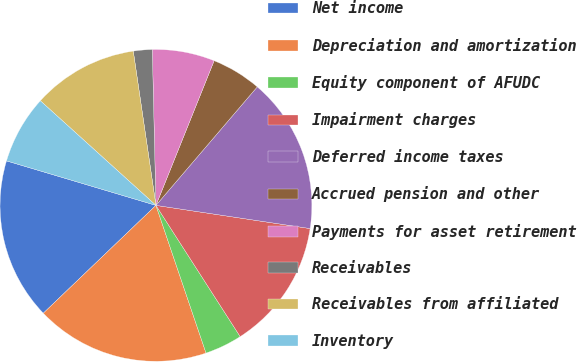Convert chart to OTSL. <chart><loc_0><loc_0><loc_500><loc_500><pie_chart><fcel>Net income<fcel>Depreciation and amortization<fcel>Equity component of AFUDC<fcel>Impairment charges<fcel>Deferred income taxes<fcel>Accrued pension and other<fcel>Payments for asset retirement<fcel>Receivables<fcel>Receivables from affiliated<fcel>Inventory<nl><fcel>16.76%<fcel>18.05%<fcel>3.88%<fcel>13.54%<fcel>16.12%<fcel>5.17%<fcel>6.46%<fcel>1.95%<fcel>10.97%<fcel>7.1%<nl></chart> 